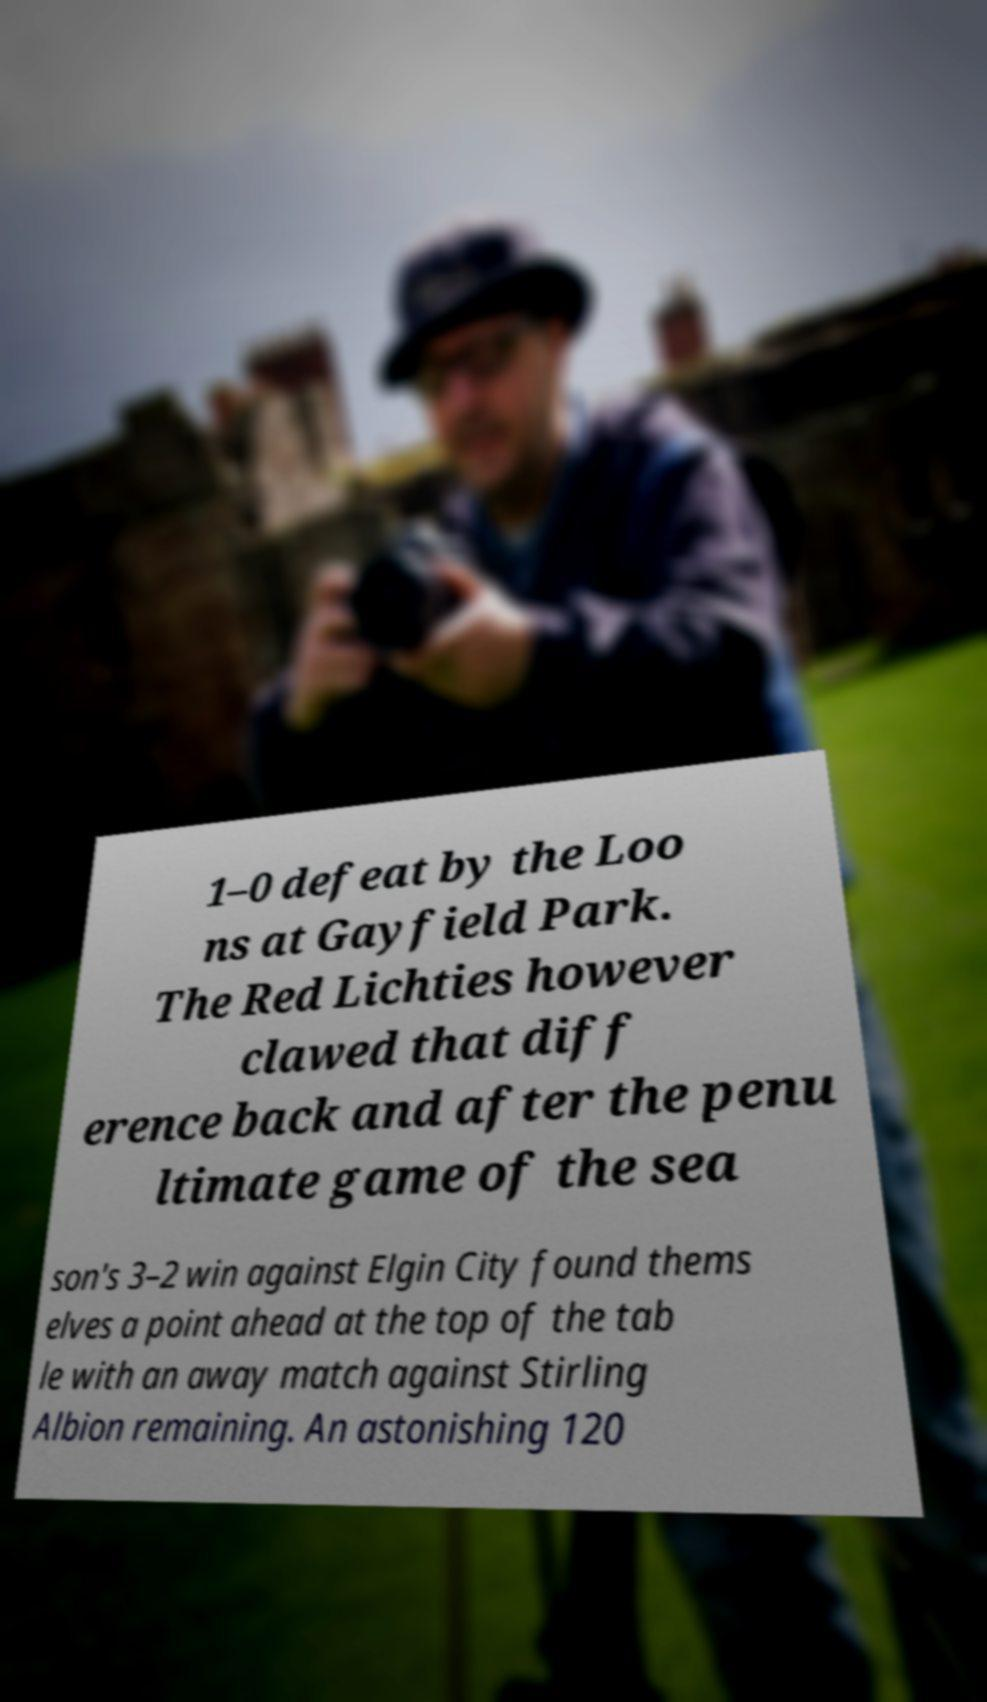Can you accurately transcribe the text from the provided image for me? 1–0 defeat by the Loo ns at Gayfield Park. The Red Lichties however clawed that diff erence back and after the penu ltimate game of the sea son's 3–2 win against Elgin City found thems elves a point ahead at the top of the tab le with an away match against Stirling Albion remaining. An astonishing 120 